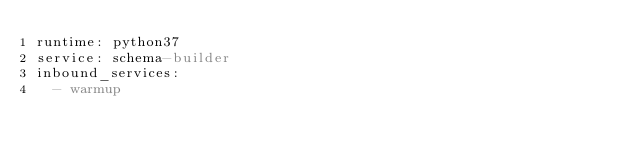Convert code to text. <code><loc_0><loc_0><loc_500><loc_500><_YAML_>runtime: python37
service: schema-builder
inbound_services:
  - warmup
</code> 